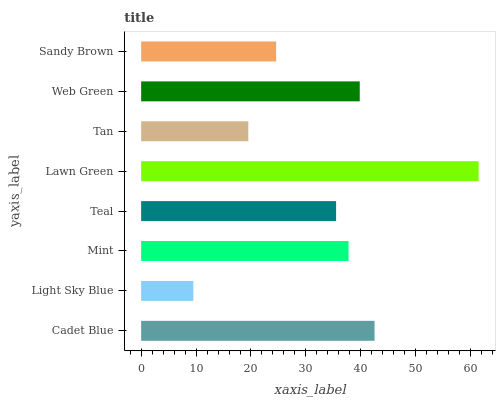Is Light Sky Blue the minimum?
Answer yes or no. Yes. Is Lawn Green the maximum?
Answer yes or no. Yes. Is Mint the minimum?
Answer yes or no. No. Is Mint the maximum?
Answer yes or no. No. Is Mint greater than Light Sky Blue?
Answer yes or no. Yes. Is Light Sky Blue less than Mint?
Answer yes or no. Yes. Is Light Sky Blue greater than Mint?
Answer yes or no. No. Is Mint less than Light Sky Blue?
Answer yes or no. No. Is Mint the high median?
Answer yes or no. Yes. Is Teal the low median?
Answer yes or no. Yes. Is Light Sky Blue the high median?
Answer yes or no. No. Is Tan the low median?
Answer yes or no. No. 